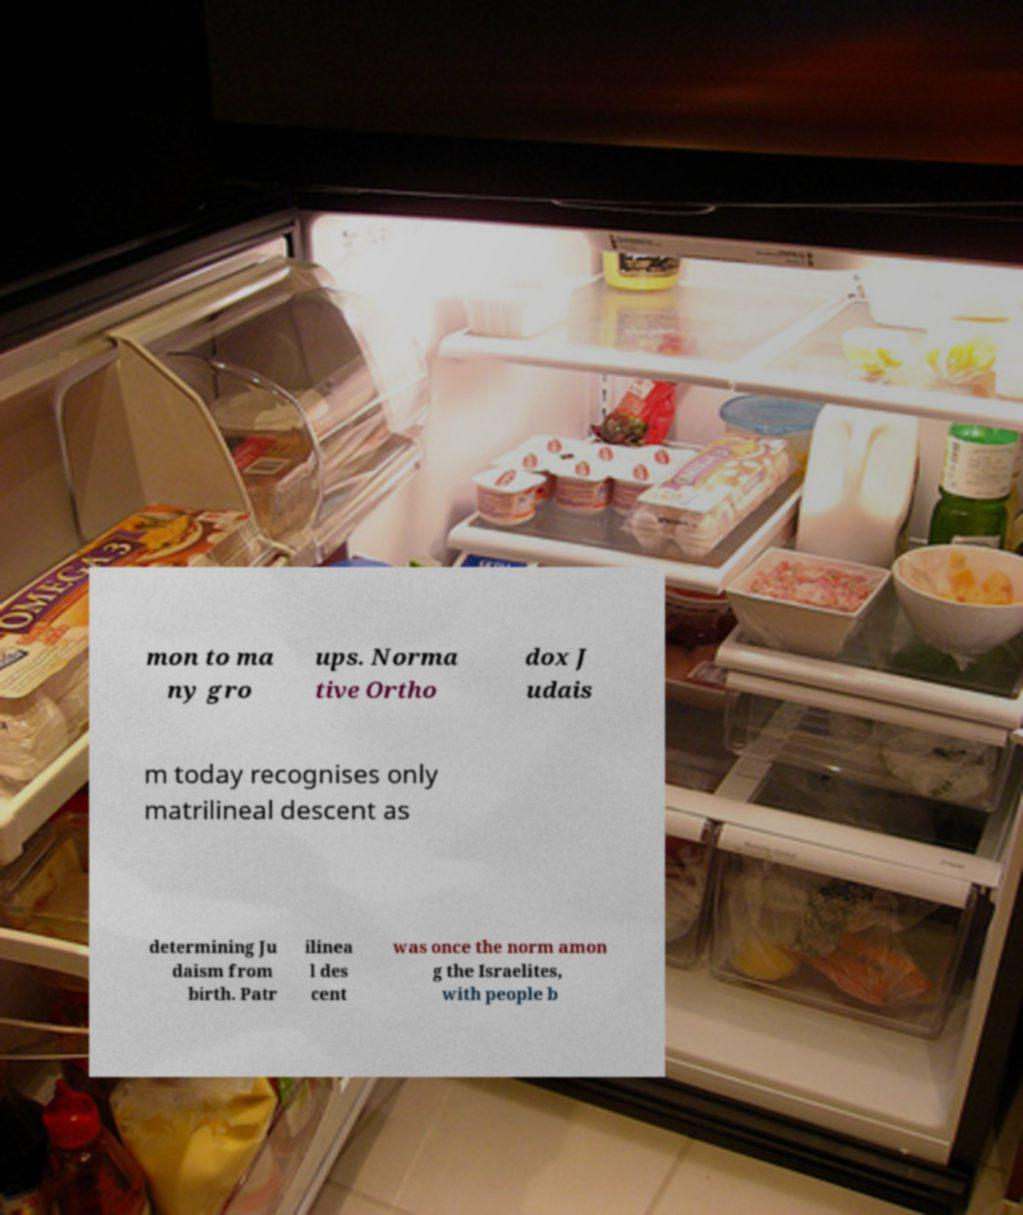There's text embedded in this image that I need extracted. Can you transcribe it verbatim? mon to ma ny gro ups. Norma tive Ortho dox J udais m today recognises only matrilineal descent as determining Ju daism from birth. Patr ilinea l des cent was once the norm amon g the Israelites, with people b 